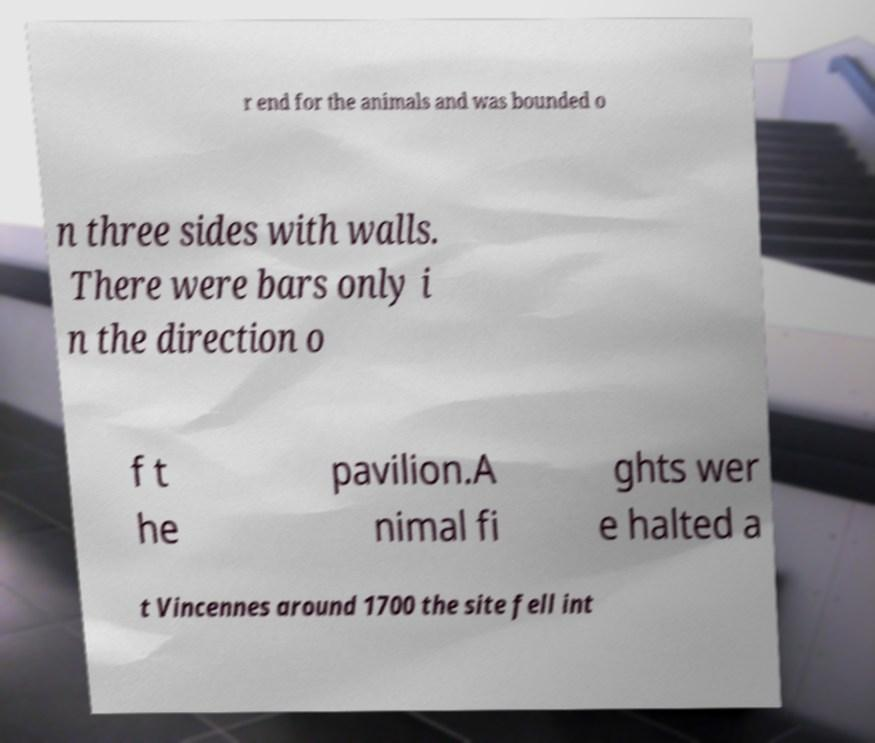Can you accurately transcribe the text from the provided image for me? r end for the animals and was bounded o n three sides with walls. There were bars only i n the direction o f t he pavilion.A nimal fi ghts wer e halted a t Vincennes around 1700 the site fell int 